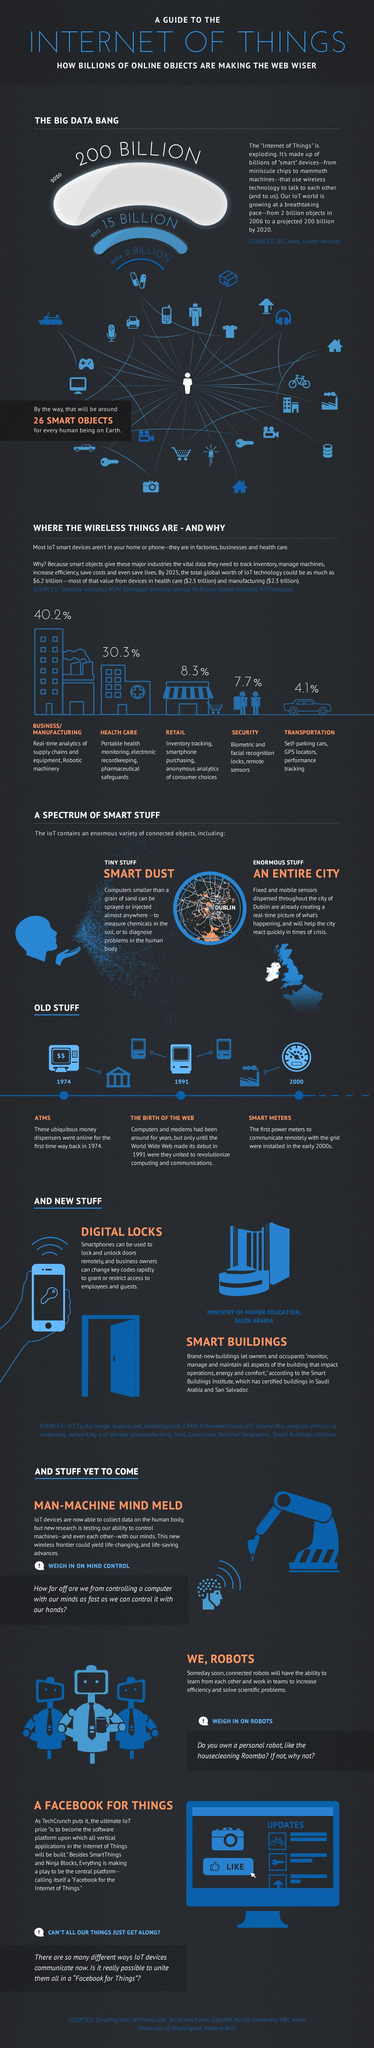Specify some key components in this picture. According to estimates, only 8.3% of IoT technology is currently used in the retail industry. The industry that uses the Internet of Things (IoT) the most is business and manufacturing. 